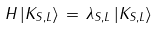<formula> <loc_0><loc_0><loc_500><loc_500>H \, | K _ { S , L } \rangle \, = \, \lambda _ { S , L } \, | K _ { S , L } \rangle</formula> 